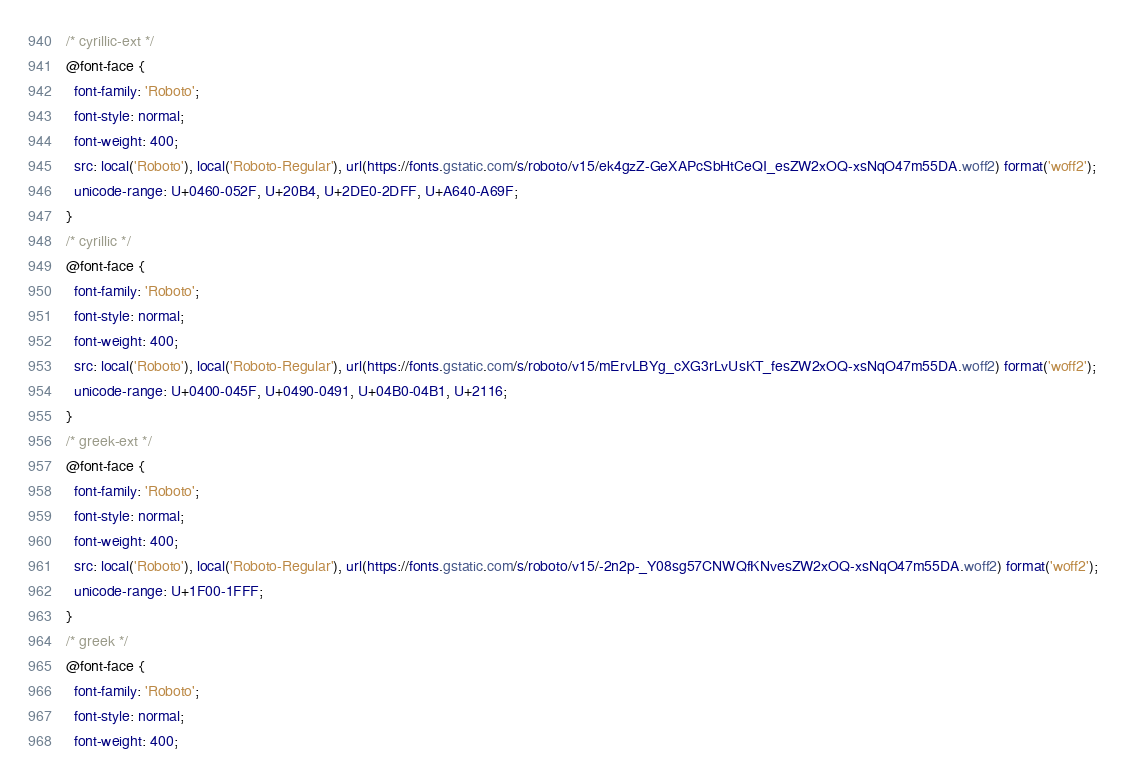<code> <loc_0><loc_0><loc_500><loc_500><_CSS_>/* cyrillic-ext */
@font-face {
  font-family: 'Roboto';
  font-style: normal;
  font-weight: 400;
  src: local('Roboto'), local('Roboto-Regular'), url(https://fonts.gstatic.com/s/roboto/v15/ek4gzZ-GeXAPcSbHtCeQI_esZW2xOQ-xsNqO47m55DA.woff2) format('woff2');
  unicode-range: U+0460-052F, U+20B4, U+2DE0-2DFF, U+A640-A69F;
}
/* cyrillic */
@font-face {
  font-family: 'Roboto';
  font-style: normal;
  font-weight: 400;
  src: local('Roboto'), local('Roboto-Regular'), url(https://fonts.gstatic.com/s/roboto/v15/mErvLBYg_cXG3rLvUsKT_fesZW2xOQ-xsNqO47m55DA.woff2) format('woff2');
  unicode-range: U+0400-045F, U+0490-0491, U+04B0-04B1, U+2116;
}
/* greek-ext */
@font-face {
  font-family: 'Roboto';
  font-style: normal;
  font-weight: 400;
  src: local('Roboto'), local('Roboto-Regular'), url(https://fonts.gstatic.com/s/roboto/v15/-2n2p-_Y08sg57CNWQfKNvesZW2xOQ-xsNqO47m55DA.woff2) format('woff2');
  unicode-range: U+1F00-1FFF;
}
/* greek */
@font-face {
  font-family: 'Roboto';
  font-style: normal;
  font-weight: 400;</code> 